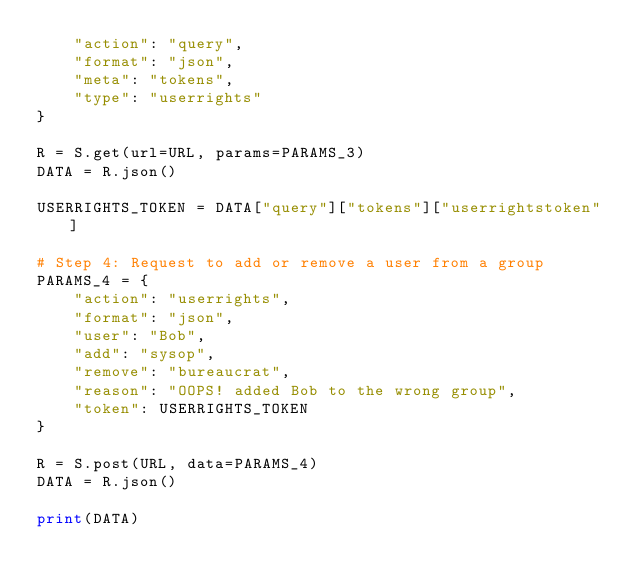Convert code to text. <code><loc_0><loc_0><loc_500><loc_500><_Python_>    "action": "query",
    "format": "json",
    "meta": "tokens",
    "type": "userrights"
}

R = S.get(url=URL, params=PARAMS_3)
DATA = R.json()

USERRIGHTS_TOKEN = DATA["query"]["tokens"]["userrightstoken"]

# Step 4: Request to add or remove a user from a group
PARAMS_4 = {
    "action": "userrights",
    "format": "json",
    "user": "Bob",
    "add": "sysop",
    "remove": "bureaucrat",
    "reason": "OOPS! added Bob to the wrong group",
    "token": USERRIGHTS_TOKEN
}

R = S.post(URL, data=PARAMS_4)
DATA = R.json()

print(DATA)
</code> 